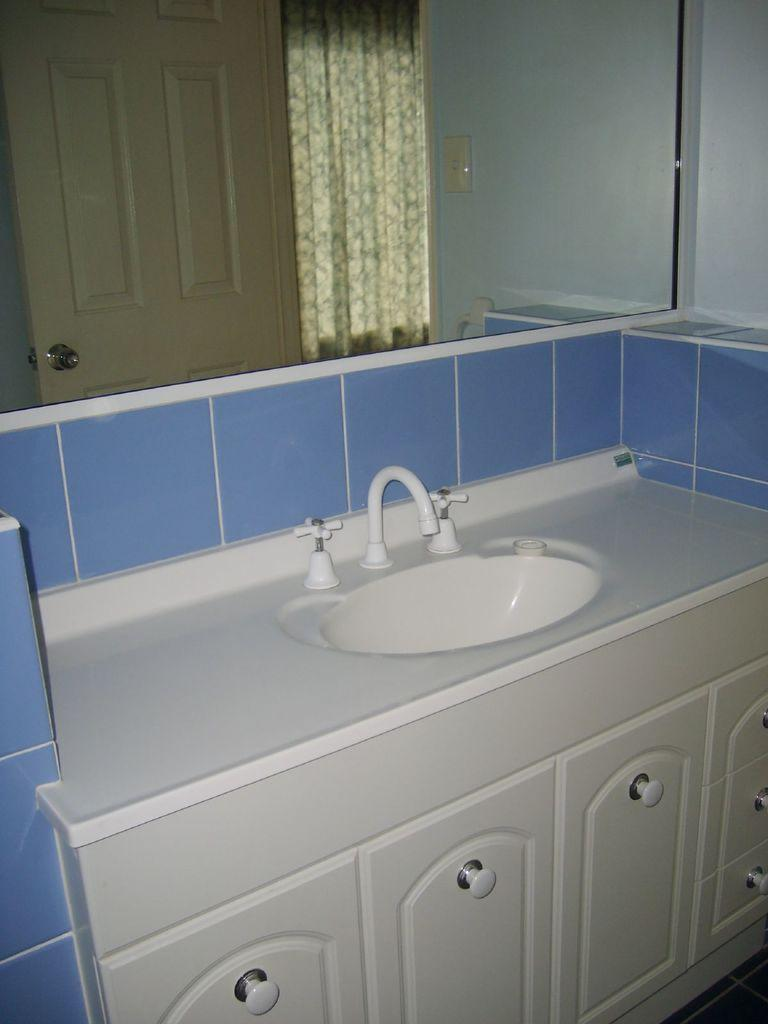Where was the image taken? The image was taken in a washroom. What objects are in the foreground of the image? There is a closet, a sink, a tap, and a mirror in the foreground of the image. What does the mirror reflect in the image? The mirror reflects the door in the image. Is there any fabric element in the image? Yes, there is a curtain in the image. What type of authority figure can be seen in the image? There is no authority figure present in the image. What material is the sink made of in the image? The facts provided do not mention the material of the sink. 